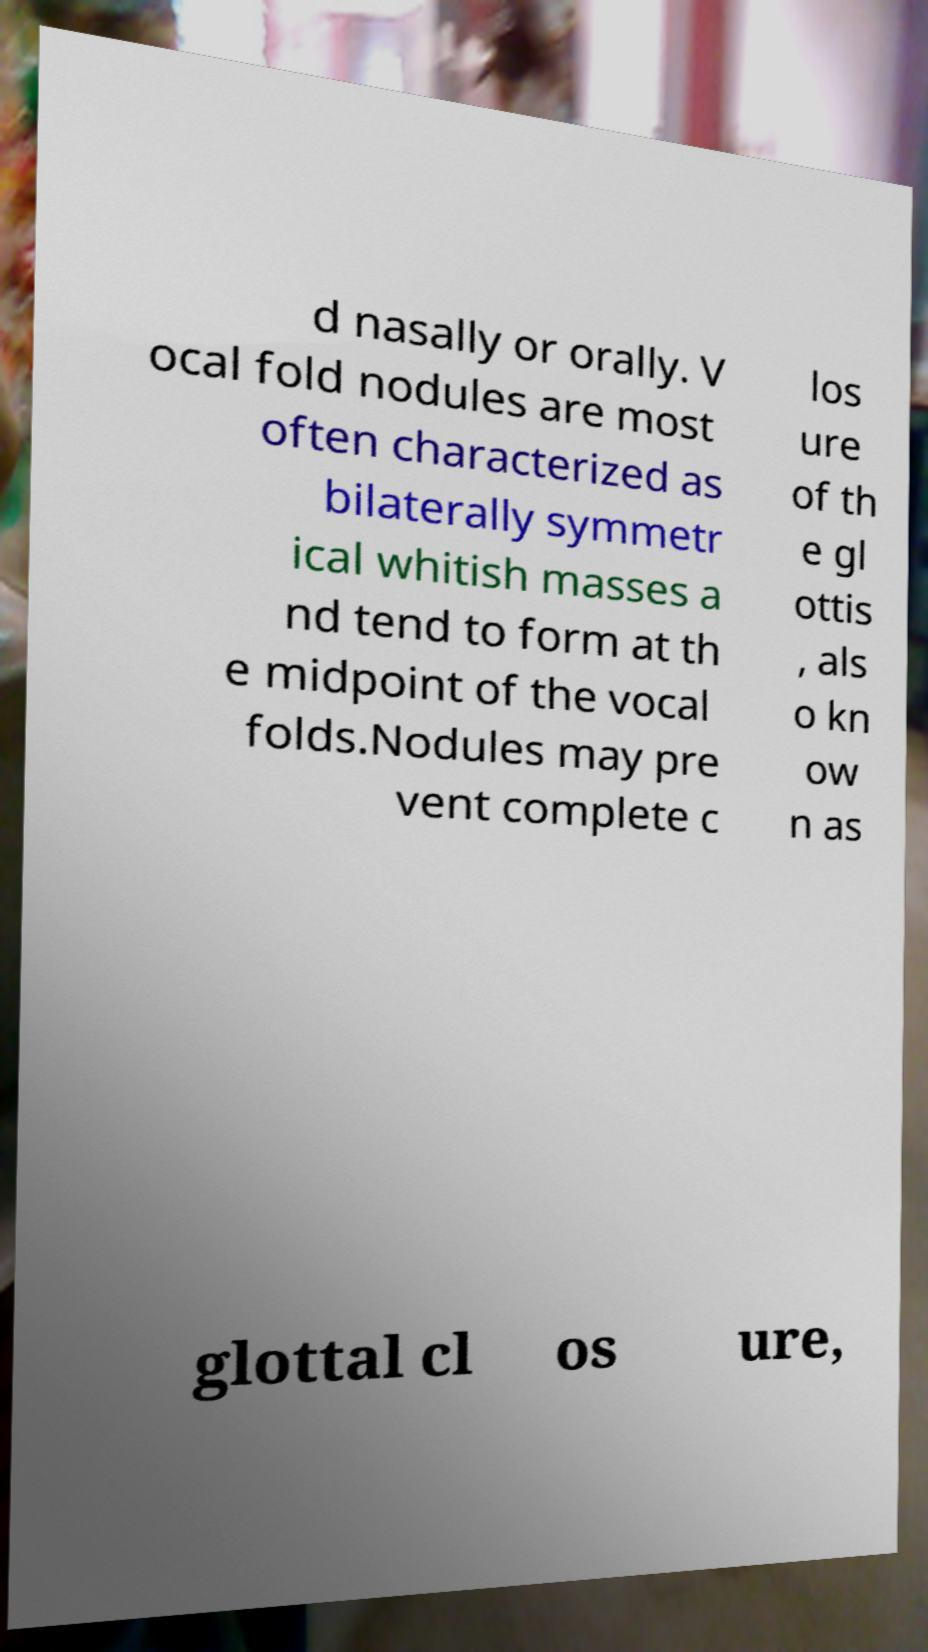There's text embedded in this image that I need extracted. Can you transcribe it verbatim? d nasally or orally. V ocal fold nodules are most often characterized as bilaterally symmetr ical whitish masses a nd tend to form at th e midpoint of the vocal folds.Nodules may pre vent complete c los ure of th e gl ottis , als o kn ow n as glottal cl os ure, 